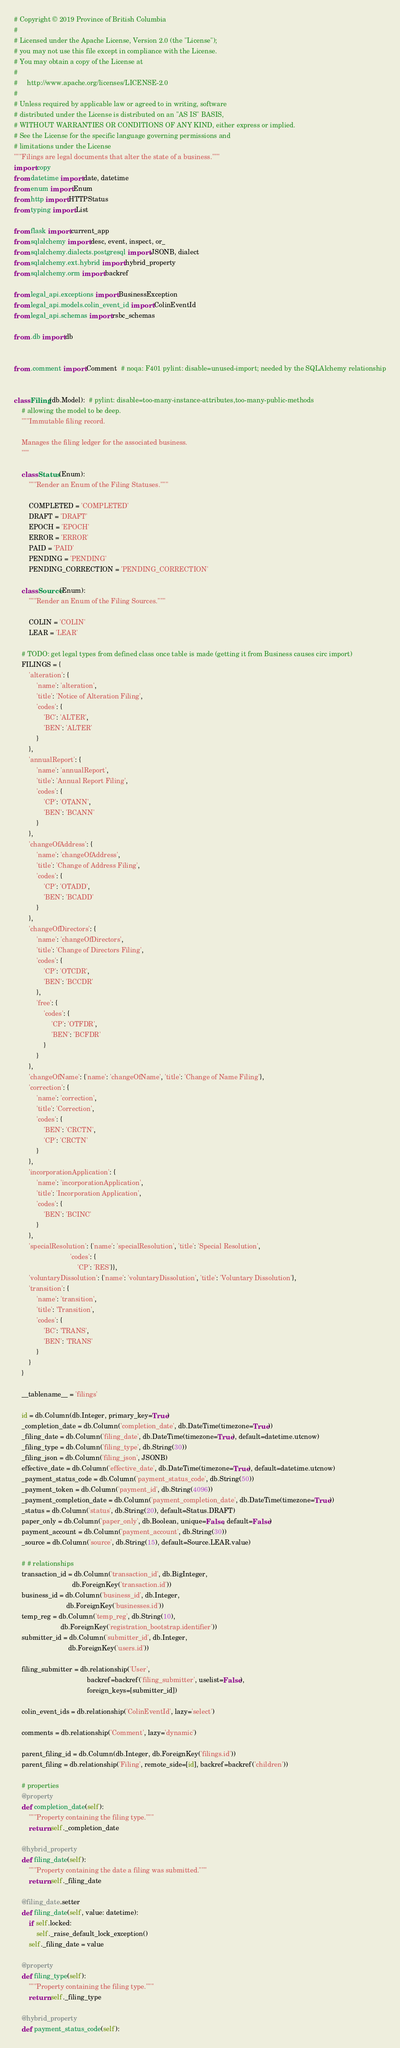Convert code to text. <code><loc_0><loc_0><loc_500><loc_500><_Python_># Copyright © 2019 Province of British Columbia
#
# Licensed under the Apache License, Version 2.0 (the "License");
# you may not use this file except in compliance with the License.
# You may obtain a copy of the License at
#
#     http://www.apache.org/licenses/LICENSE-2.0
#
# Unless required by applicable law or agreed to in writing, software
# distributed under the License is distributed on an "AS IS" BASIS,
# WITHOUT WARRANTIES OR CONDITIONS OF ANY KIND, either express or implied.
# See the License for the specific language governing permissions and
# limitations under the License
"""Filings are legal documents that alter the state of a business."""
import copy
from datetime import date, datetime
from enum import Enum
from http import HTTPStatus
from typing import List

from flask import current_app
from sqlalchemy import desc, event, inspect, or_
from sqlalchemy.dialects.postgresql import JSONB, dialect
from sqlalchemy.ext.hybrid import hybrid_property
from sqlalchemy.orm import backref

from legal_api.exceptions import BusinessException
from legal_api.models.colin_event_id import ColinEventId
from legal_api.schemas import rsbc_schemas

from .db import db


from .comment import Comment  # noqa: F401 pylint: disable=unused-import; needed by the SQLAlchemy relationship


class Filing(db.Model):  # pylint: disable=too-many-instance-attributes,too-many-public-methods
    # allowing the model to be deep.
    """Immutable filing record.

    Manages the filing ledger for the associated business.
    """

    class Status(Enum):
        """Render an Enum of the Filing Statuses."""

        COMPLETED = 'COMPLETED'
        DRAFT = 'DRAFT'
        EPOCH = 'EPOCH'
        ERROR = 'ERROR'
        PAID = 'PAID'
        PENDING = 'PENDING'
        PENDING_CORRECTION = 'PENDING_CORRECTION'

    class Source(Enum):
        """Render an Enum of the Filing Sources."""

        COLIN = 'COLIN'
        LEAR = 'LEAR'

    # TODO: get legal types from defined class once table is made (getting it from Business causes circ import)
    FILINGS = {
        'alteration': {
            'name': 'alteration',
            'title': 'Notice of Alteration Filing',
            'codes': {
                'BC': 'ALTER',
                'BEN': 'ALTER'
            }
        },
        'annualReport': {
            'name': 'annualReport',
            'title': 'Annual Report Filing',
            'codes': {
                'CP': 'OTANN',
                'BEN': 'BCANN'
            }
        },
        'changeOfAddress': {
            'name': 'changeOfAddress',
            'title': 'Change of Address Filing',
            'codes': {
                'CP': 'OTADD',
                'BEN': 'BCADD'
            }
        },
        'changeOfDirectors': {
            'name': 'changeOfDirectors',
            'title': 'Change of Directors Filing',
            'codes': {
                'CP': 'OTCDR',
                'BEN': 'BCCDR'
            },
            'free': {
                'codes': {
                    'CP': 'OTFDR',
                    'BEN': 'BCFDR'
                }
            }
        },
        'changeOfName': {'name': 'changeOfName', 'title': 'Change of Name Filing'},
        'correction': {
            'name': 'correction',
            'title': 'Correction',
            'codes': {
                'BEN': 'CRCTN',
                'CP': 'CRCTN'
            }
        },
        'incorporationApplication': {
            'name': 'incorporationApplication',
            'title': 'Incorporation Application',
            'codes': {
                'BEN': 'BCINC'
            }
        },
        'specialResolution': {'name': 'specialResolution', 'title': 'Special Resolution',
                              'codes': {
                                  'CP': 'RES'}},
        'voluntaryDissolution': {'name': 'voluntaryDissolution', 'title': 'Voluntary Dissolution'},
        'transition': {
            'name': 'transition',
            'title': 'Transition',
            'codes': {
                'BC': 'TRANS',
                'BEN': 'TRANS'
            }
        }
    }

    __tablename__ = 'filings'

    id = db.Column(db.Integer, primary_key=True)
    _completion_date = db.Column('completion_date', db.DateTime(timezone=True))
    _filing_date = db.Column('filing_date', db.DateTime(timezone=True), default=datetime.utcnow)
    _filing_type = db.Column('filing_type', db.String(30))
    _filing_json = db.Column('filing_json', JSONB)
    effective_date = db.Column('effective_date', db.DateTime(timezone=True), default=datetime.utcnow)
    _payment_status_code = db.Column('payment_status_code', db.String(50))
    _payment_token = db.Column('payment_id', db.String(4096))
    _payment_completion_date = db.Column('payment_completion_date', db.DateTime(timezone=True))
    _status = db.Column('status', db.String(20), default=Status.DRAFT)
    paper_only = db.Column('paper_only', db.Boolean, unique=False, default=False)
    payment_account = db.Column('payment_account', db.String(30))
    _source = db.Column('source', db.String(15), default=Source.LEAR.value)

    # # relationships
    transaction_id = db.Column('transaction_id', db.BigInteger,
                               db.ForeignKey('transaction.id'))
    business_id = db.Column('business_id', db.Integer,
                            db.ForeignKey('businesses.id'))
    temp_reg = db.Column('temp_reg', db.String(10),
                         db.ForeignKey('registration_bootstrap.identifier'))
    submitter_id = db.Column('submitter_id', db.Integer,
                             db.ForeignKey('users.id'))

    filing_submitter = db.relationship('User',
                                       backref=backref('filing_submitter', uselist=False),
                                       foreign_keys=[submitter_id])

    colin_event_ids = db.relationship('ColinEventId', lazy='select')

    comments = db.relationship('Comment', lazy='dynamic')

    parent_filing_id = db.Column(db.Integer, db.ForeignKey('filings.id'))
    parent_filing = db.relationship('Filing', remote_side=[id], backref=backref('children'))

    # properties
    @property
    def completion_date(self):
        """Property containing the filing type."""
        return self._completion_date

    @hybrid_property
    def filing_date(self):
        """Property containing the date a filing was submitted."""
        return self._filing_date

    @filing_date.setter
    def filing_date(self, value: datetime):
        if self.locked:
            self._raise_default_lock_exception()
        self._filing_date = value

    @property
    def filing_type(self):
        """Property containing the filing type."""
        return self._filing_type

    @hybrid_property
    def payment_status_code(self):</code> 